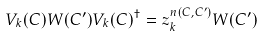<formula> <loc_0><loc_0><loc_500><loc_500>V _ { k } ( C ) W ( C ^ { \prime } ) V _ { k } ( C ) ^ { \dagger } = z _ { k } ^ { n ( C , C ^ { \prime } ) } W ( C ^ { \prime } )</formula> 